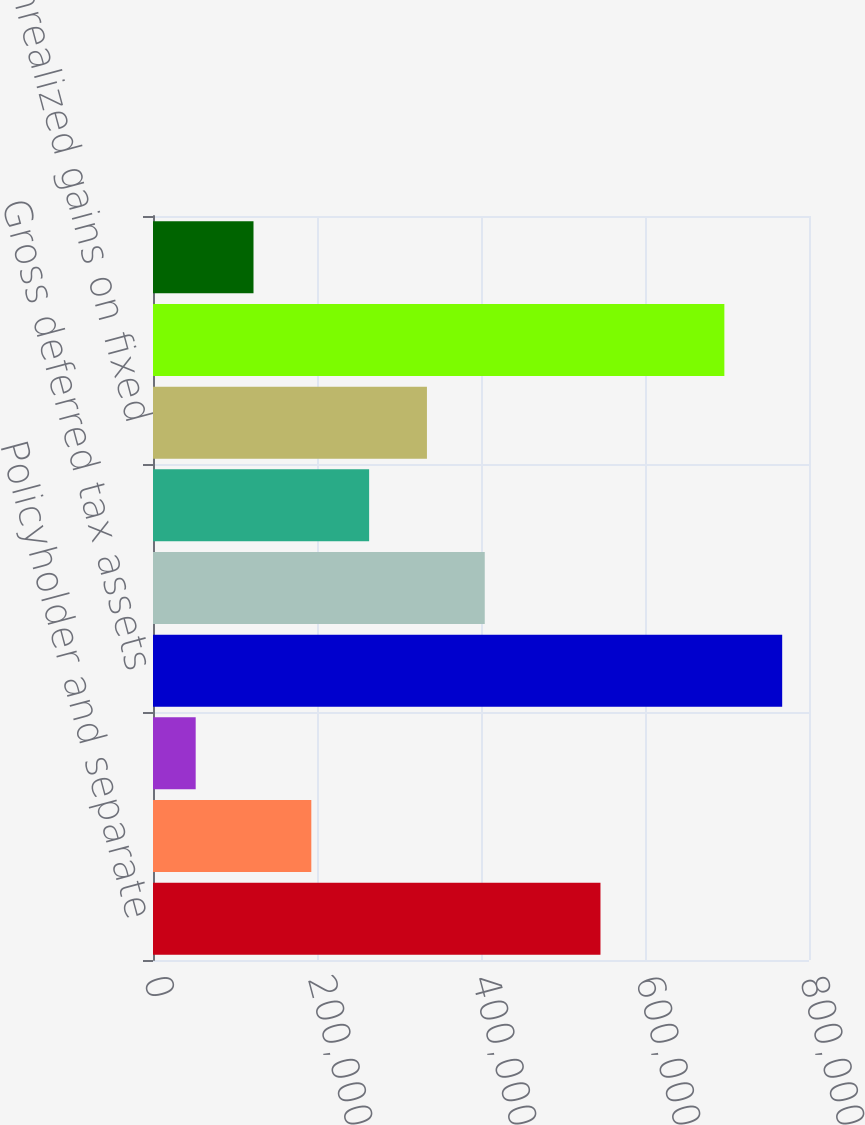Convert chart to OTSL. <chart><loc_0><loc_0><loc_500><loc_500><bar_chart><fcel>Policyholder and separate<fcel>Accrued liabilities<fcel>Investment adjustments<fcel>Gross deferred tax assets<fcel>Deferred acquisition costs<fcel>Other assets<fcel>Unrealized gains on fixed<fcel>Gross deferred tax liabilities<fcel>Net deferred income tax<nl><fcel>545699<fcel>193067<fcel>52056<fcel>767296<fcel>404584<fcel>263572<fcel>334078<fcel>696790<fcel>122562<nl></chart> 